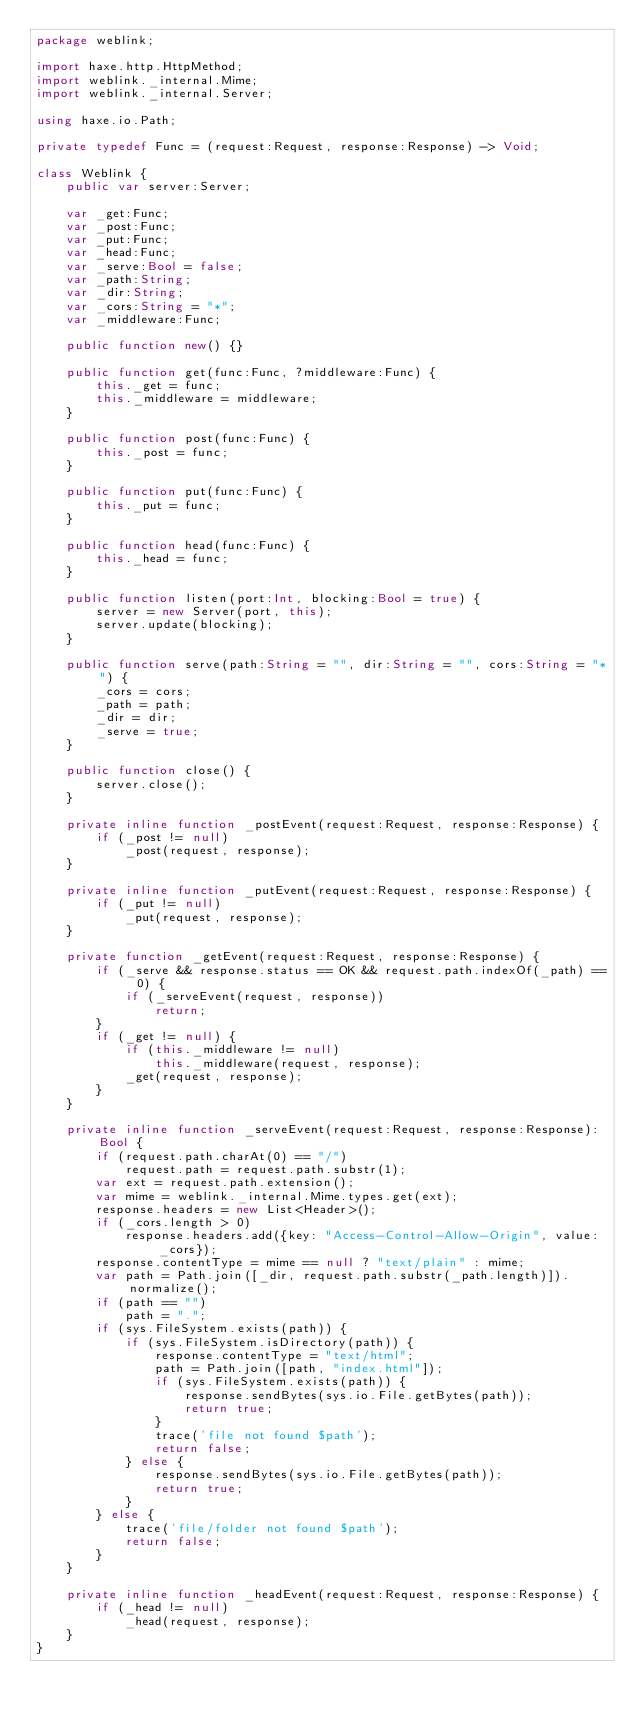Convert code to text. <code><loc_0><loc_0><loc_500><loc_500><_Haxe_>package weblink;

import haxe.http.HttpMethod;
import weblink._internal.Mime;
import weblink._internal.Server;

using haxe.io.Path;

private typedef Func = (request:Request, response:Response) -> Void;

class Weblink {
	public var server:Server;

	var _get:Func;
	var _post:Func;
	var _put:Func;
	var _head:Func;
	var _serve:Bool = false;
	var _path:String;
	var _dir:String;
	var _cors:String = "*";
	var _middleware:Func;

	public function new() {}

	public function get(func:Func, ?middleware:Func) {
		this._get = func;
		this._middleware = middleware;
	}

	public function post(func:Func) {
		this._post = func;
	}

	public function put(func:Func) {
		this._put = func;
	}

	public function head(func:Func) {
		this._head = func;
	}

	public function listen(port:Int, blocking:Bool = true) {
		server = new Server(port, this);
		server.update(blocking);
	}

	public function serve(path:String = "", dir:String = "", cors:String = "*") {
		_cors = cors;
		_path = path;
		_dir = dir;
		_serve = true;
	}

	public function close() {
		server.close();
	}

	private inline function _postEvent(request:Request, response:Response) {
		if (_post != null)
			_post(request, response);
	}

	private inline function _putEvent(request:Request, response:Response) {
		if (_put != null)
			_put(request, response);
	}

	private function _getEvent(request:Request, response:Response) {
		if (_serve && response.status == OK && request.path.indexOf(_path) == 0) {
			if (_serveEvent(request, response))
				return;
		}
		if (_get != null) {
			if (this._middleware != null)
				this._middleware(request, response);
			_get(request, response);
		}
	}

	private inline function _serveEvent(request:Request, response:Response):Bool {
		if (request.path.charAt(0) == "/")
			request.path = request.path.substr(1);
		var ext = request.path.extension();
		var mime = weblink._internal.Mime.types.get(ext);
		response.headers = new List<Header>();
		if (_cors.length > 0)
			response.headers.add({key: "Access-Control-Allow-Origin", value: _cors});
		response.contentType = mime == null ? "text/plain" : mime;
		var path = Path.join([_dir, request.path.substr(_path.length)]).normalize();
		if (path == "")
			path = ".";
		if (sys.FileSystem.exists(path)) {
			if (sys.FileSystem.isDirectory(path)) {
				response.contentType = "text/html";
				path = Path.join([path, "index.html"]);
				if (sys.FileSystem.exists(path)) {
					response.sendBytes(sys.io.File.getBytes(path));
					return true;
				}
				trace('file not found $path');
				return false;
			} else {
				response.sendBytes(sys.io.File.getBytes(path));
				return true;
			}
		} else {
			trace('file/folder not found $path');
			return false;
		}
	}

	private inline function _headEvent(request:Request, response:Response) {
		if (_head != null)
			_head(request, response);
	}
}
</code> 